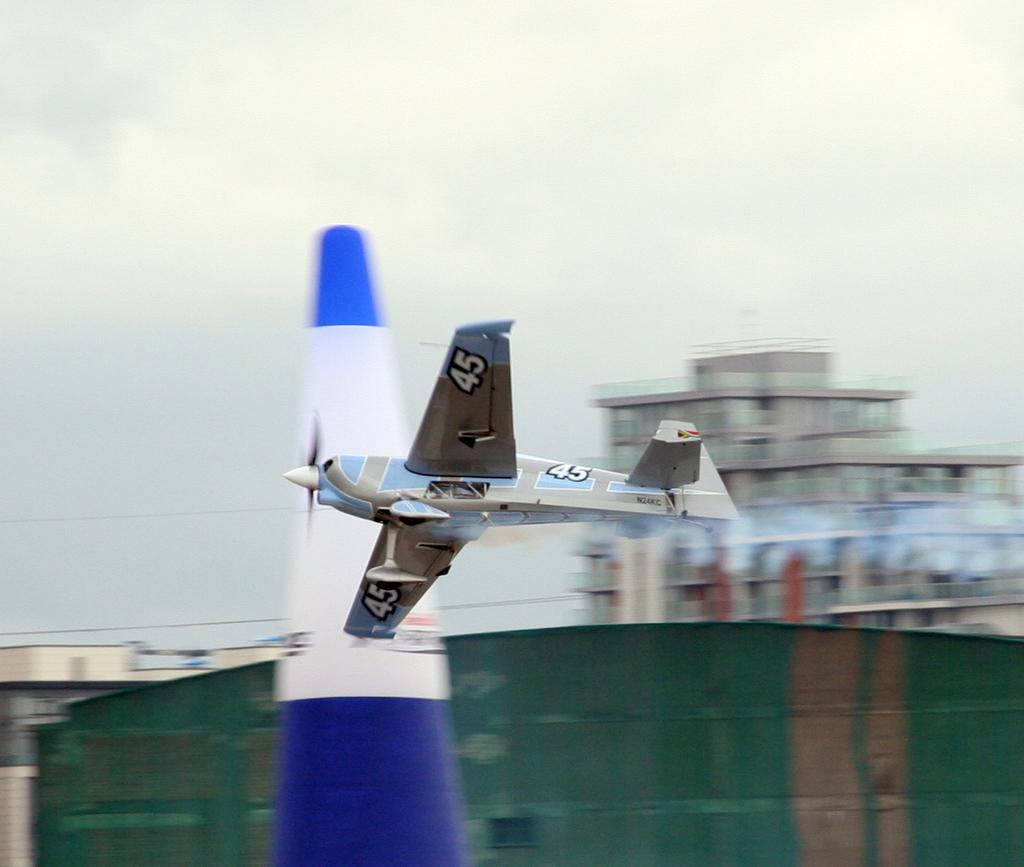What number is on the planes wing?
Keep it short and to the point. 45. 